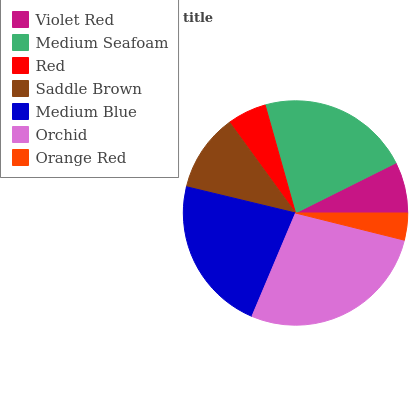Is Orange Red the minimum?
Answer yes or no. Yes. Is Orchid the maximum?
Answer yes or no. Yes. Is Medium Seafoam the minimum?
Answer yes or no. No. Is Medium Seafoam the maximum?
Answer yes or no. No. Is Medium Seafoam greater than Violet Red?
Answer yes or no. Yes. Is Violet Red less than Medium Seafoam?
Answer yes or no. Yes. Is Violet Red greater than Medium Seafoam?
Answer yes or no. No. Is Medium Seafoam less than Violet Red?
Answer yes or no. No. Is Saddle Brown the high median?
Answer yes or no. Yes. Is Saddle Brown the low median?
Answer yes or no. Yes. Is Orchid the high median?
Answer yes or no. No. Is Medium Blue the low median?
Answer yes or no. No. 